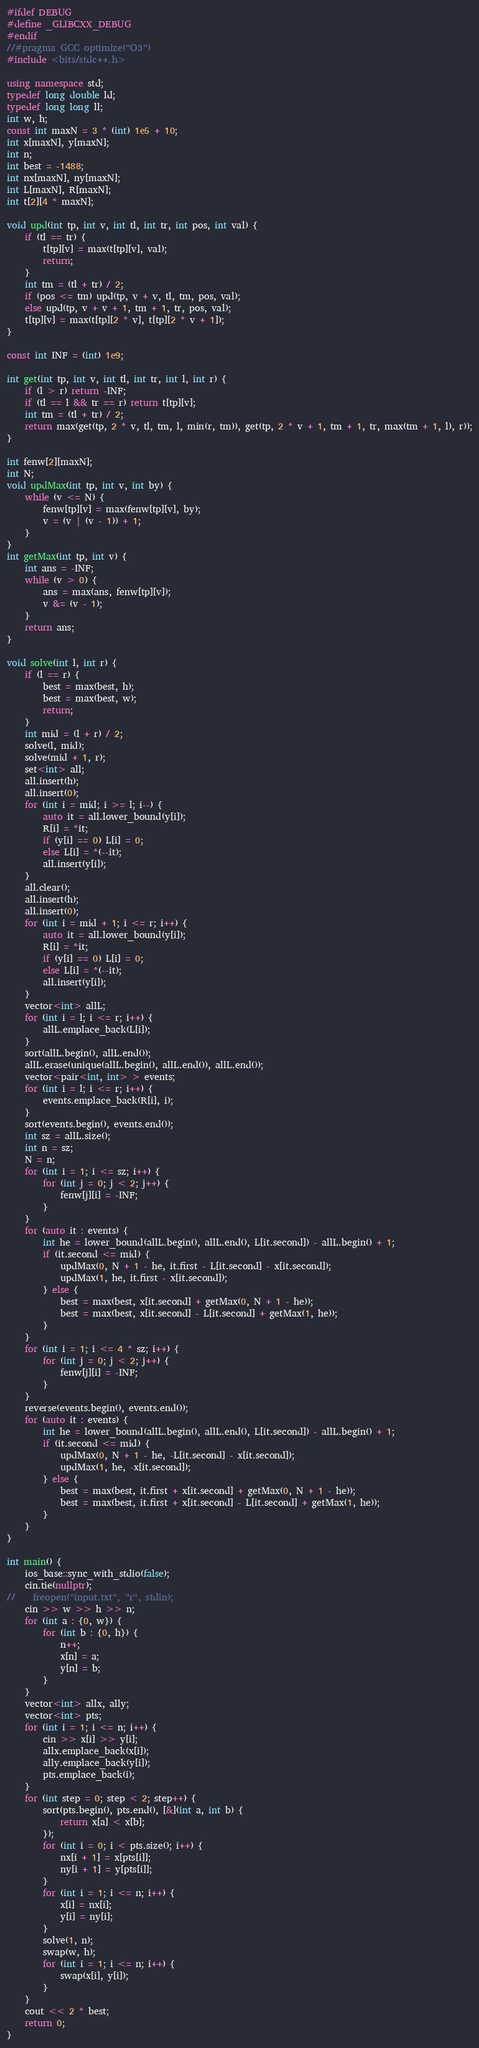Convert code to text. <code><loc_0><loc_0><loc_500><loc_500><_C++_>#ifdef DEBUG
#define _GLIBCXX_DEBUG
#endif
//#pragma GCC optimize("O3")
#include <bits/stdc++.h>

using namespace std;
typedef long double ld;
typedef long long ll;
int w, h;
const int maxN = 3 * (int) 1e5 + 10;
int x[maxN], y[maxN];
int n;
int best = -1488;
int nx[maxN], ny[maxN];
int L[maxN], R[maxN];
int t[2][4 * maxN];

void upd(int tp, int v, int tl, int tr, int pos, int val) {
    if (tl == tr) {
        t[tp][v] = max(t[tp][v], val);
        return;
    }
    int tm = (tl + tr) / 2;
    if (pos <= tm) upd(tp, v + v, tl, tm, pos, val);
    else upd(tp, v + v + 1, tm + 1, tr, pos, val);
    t[tp][v] = max(t[tp][2 * v], t[tp][2 * v + 1]);
}

const int INF = (int) 1e9;

int get(int tp, int v, int tl, int tr, int l, int r) {
    if (l > r) return -INF;
    if (tl == l && tr == r) return t[tp][v];
    int tm = (tl + tr) / 2;
    return max(get(tp, 2 * v, tl, tm, l, min(r, tm)), get(tp, 2 * v + 1, tm + 1, tr, max(tm + 1, l), r));
}

int fenw[2][maxN];
int N;
void updMax(int tp, int v, int by) {
    while (v <= N) {
        fenw[tp][v] = max(fenw[tp][v], by);
        v = (v | (v - 1)) + 1;
    }
}
int getMax(int tp, int v) {
    int ans = -INF;
    while (v > 0) {
        ans = max(ans, fenw[tp][v]);
        v &= (v - 1);
    }
    return ans;
}

void solve(int l, int r) {
    if (l == r) {
        best = max(best, h);
        best = max(best, w);
        return;
    }
    int mid = (l + r) / 2;
    solve(l, mid);
    solve(mid + 1, r);
    set<int> all;
    all.insert(h);
    all.insert(0);
    for (int i = mid; i >= l; i--) {
        auto it = all.lower_bound(y[i]);
        R[i] = *it;
        if (y[i] == 0) L[i] = 0;
        else L[i] = *(--it);
        all.insert(y[i]);
    }
    all.clear();
    all.insert(h);
    all.insert(0);
    for (int i = mid + 1; i <= r; i++) {
        auto it = all.lower_bound(y[i]);
        R[i] = *it;
        if (y[i] == 0) L[i] = 0;
        else L[i] = *(--it);
        all.insert(y[i]);
    }
    vector<int> allL;
    for (int i = l; i <= r; i++) {
        allL.emplace_back(L[i]);
    }
    sort(allL.begin(), allL.end());
    allL.erase(unique(allL.begin(), allL.end()), allL.end());
    vector<pair<int, int> > events;
    for (int i = l; i <= r; i++) {
        events.emplace_back(R[i], i);
    }
    sort(events.begin(), events.end());
    int sz = allL.size();
    int n = sz;
    N = n;
    for (int i = 1; i <= sz; i++) {
        for (int j = 0; j < 2; j++) {
            fenw[j][i] = -INF;
        }
    }
    for (auto it : events) {
        int he = lower_bound(allL.begin(), allL.end(), L[it.second]) - allL.begin() + 1;
        if (it.second <= mid) {
            updMax(0, N + 1 - he, it.first - L[it.second] - x[it.second]);
            updMax(1, he, it.first - x[it.second]);
        } else {
            best = max(best, x[it.second] + getMax(0, N + 1 - he));
            best = max(best, x[it.second] - L[it.second] + getMax(1, he));
        }
    }
    for (int i = 1; i <= 4 * sz; i++) {
        for (int j = 0; j < 2; j++) {
            fenw[j][i] = -INF;
        }
    }
    reverse(events.begin(), events.end());
    for (auto it : events) {
        int he = lower_bound(allL.begin(), allL.end(), L[it.second]) - allL.begin() + 1;
        if (it.second <= mid) {
            updMax(0, N + 1 - he, -L[it.second] - x[it.second]);
            updMax(1, he, -x[it.second]);
        } else {
            best = max(best, it.first + x[it.second] + getMax(0, N + 1 - he));
            best = max(best, it.first + x[it.second] - L[it.second] + getMax(1, he));
        }
    }
}

int main() {
    ios_base::sync_with_stdio(false);
    cin.tie(nullptr);
//    freopen("input.txt", "r", stdin);
    cin >> w >> h >> n;
    for (int a : {0, w}) {
        for (int b : {0, h}) {
            n++;
            x[n] = a;
            y[n] = b;
        }
    }
    vector<int> allx, ally;
    vector<int> pts;
    for (int i = 1; i <= n; i++) {
        cin >> x[i] >> y[i];
        allx.emplace_back(x[i]);
        ally.emplace_back(y[i]);
        pts.emplace_back(i);
    }
    for (int step = 0; step < 2; step++) {
        sort(pts.begin(), pts.end(), [&](int a, int b) {
            return x[a] < x[b];
        });
        for (int i = 0; i < pts.size(); i++) {
            nx[i + 1] = x[pts[i]];
            ny[i + 1] = y[pts[i]];
        }
        for (int i = 1; i <= n; i++) {
            x[i] = nx[i];
            y[i] = ny[i];
        }
        solve(1, n);
        swap(w, h);
        for (int i = 1; i <= n; i++) {
            swap(x[i], y[i]);
        }
    }
    cout << 2 * best;
    return 0;
}</code> 